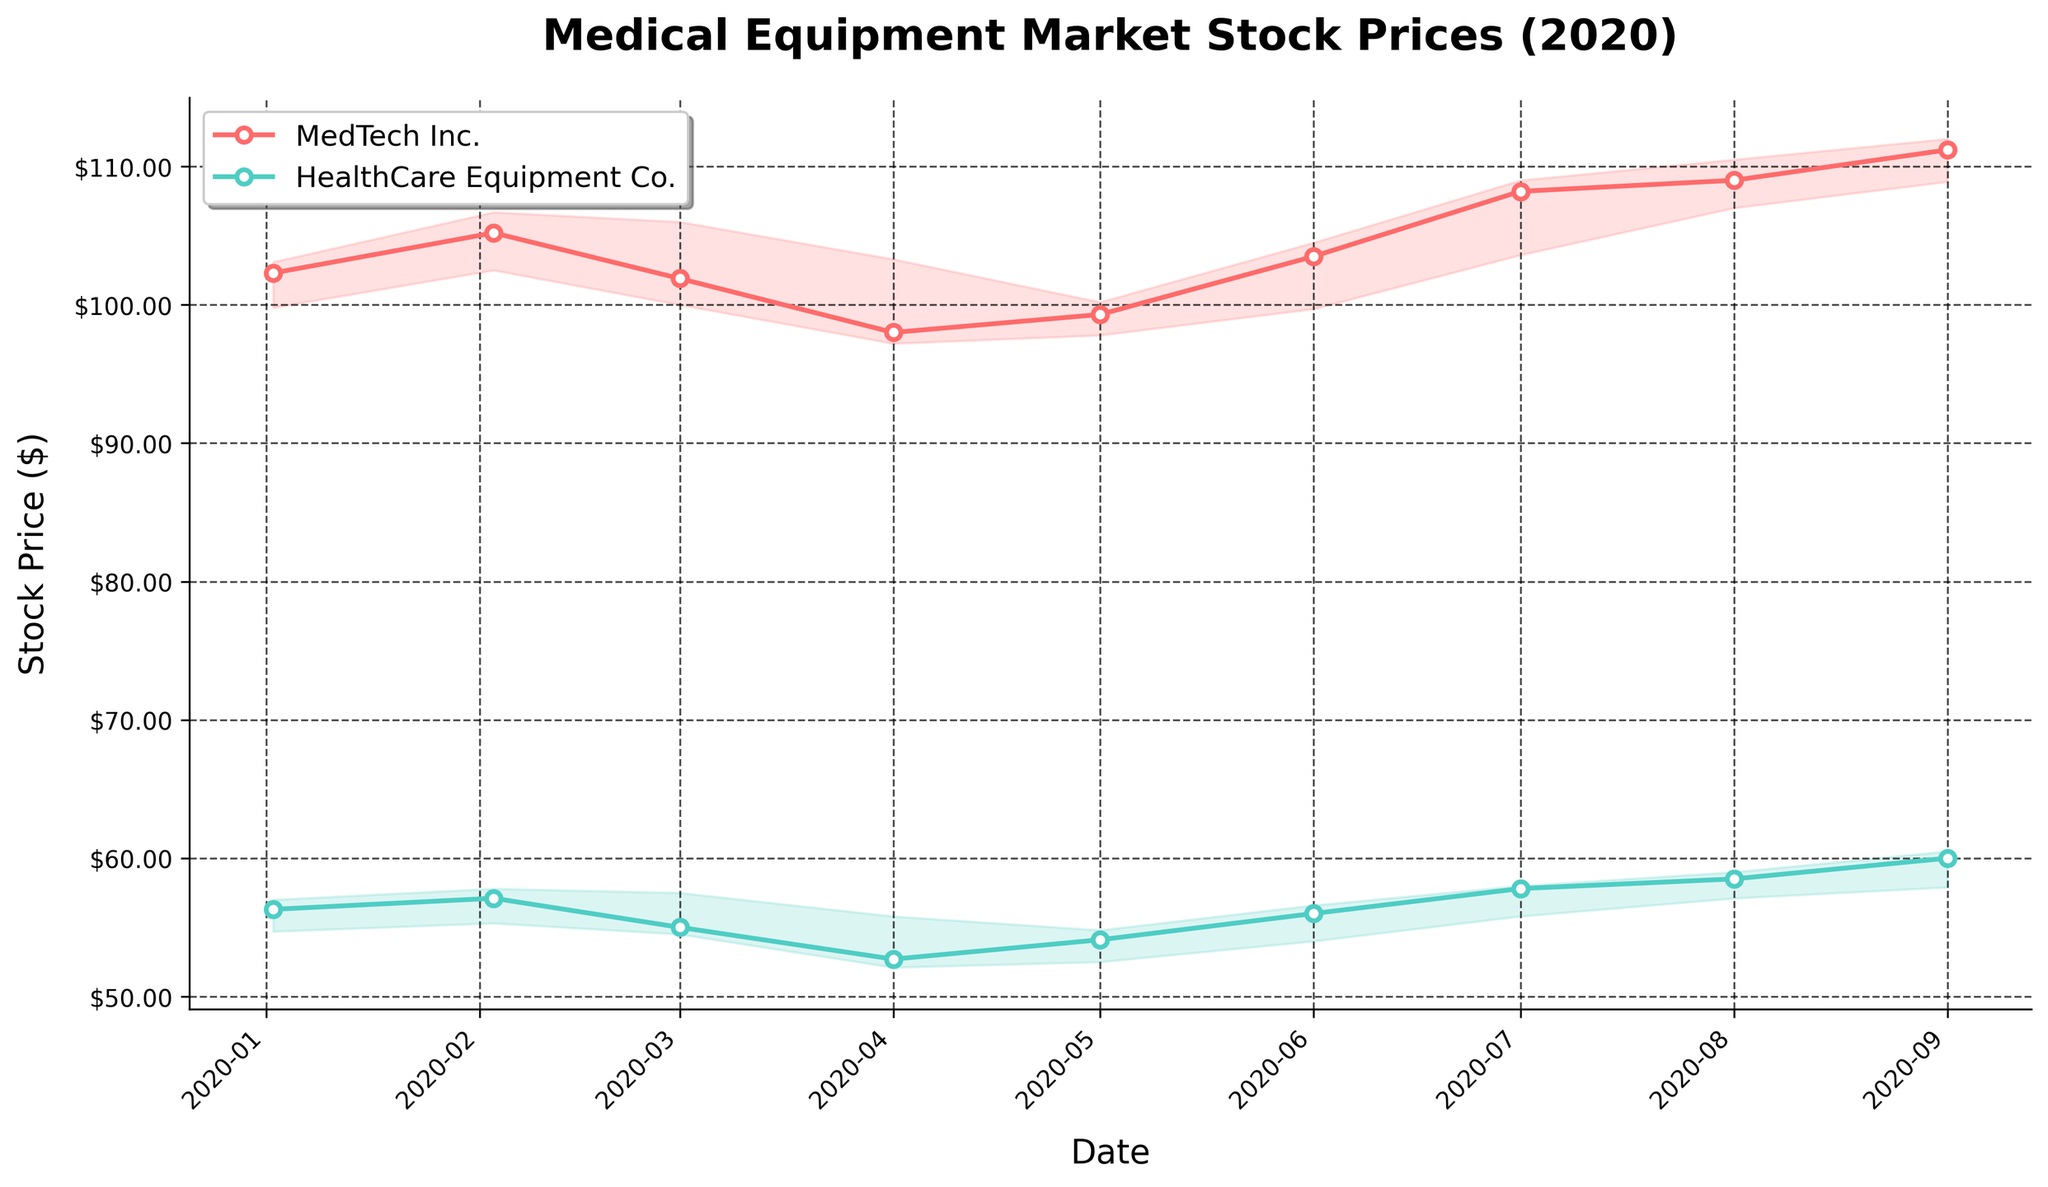What's the title of the figure? The title is usually displayed prominently at the top of the figure, describing what the figure represents. In this case, the title is "Medical Equipment Market Stock Prices (2020)" which gives an overview of the stock prices for medical equipment companies throughout 2020.
Answer: Medical Equipment Market Stock Prices (2020) What companies are depicted in the plot? The labels within the plot legend indicate the companies. According to the figure, the companies shown are "MedTech Inc." and "HealthCare Equipment Co.".
Answer: MedTech Inc. and HealthCare Equipment Co Which month has the highest closing price for MedTech Inc.? By examining the plot line for MedTech Inc. and locating the peak, the highest point noted for the closing price is in July 2020.
Answer: July 2020 What is the lowest price recorded by HealthCare Equipment Co. during 2020? By checking the filled areas along the bottom edge representing the lowest prices for HealthCare Equipment Co., the lowest value appears in April 2020.
Answer: April 2020 How does the stock price range change for MedTech Inc. from January to June 2020? Comparing the filled areas between the lowest and highest prices from January to June for MedTech Inc., the range initially narrows and then broadens slightly as prices become more volatile. This shows the shifting market dynamics over these months.
Answer: Narrows then broadens Is there a month where both companies experience an increase in their closing prices? Tracking the closing prices for both companies across the months, an increase for both can be observed between April and May 2020, and between June and July 2020.
Answer: May 2020 and July 2020 Which company shows more volatility in their stock prices and how can you tell? Volatility can be assessed by the span between the lowest and highest prices. HealthCare Equipment Co. shows larger gaps between the lowest and highest prices consistently, indicating more volatility. This is particularly visible in the months where the filled area is more significant.
Answer: HealthCare Equipment Co What is the difference in closing prices between January and September 2020 for MedTech Inc.? By locating and subtracting the closing prices for MedTech Inc. in January ($102.3) and September ($111.2), the difference is calculated as $111.2 - $102.3.
Answer: $8.9 Which company had a significantly higher trading volume and during what period? From the figure legend labels or axis annotations, examining periods with filled colors, HealthCare Equipment Co. had higher trading volumes consistently throughout 2020 compared to MedTech Inc., specifically in April and May 2020.
Answer: HealthCare Equipment Co. in April and May 2020 